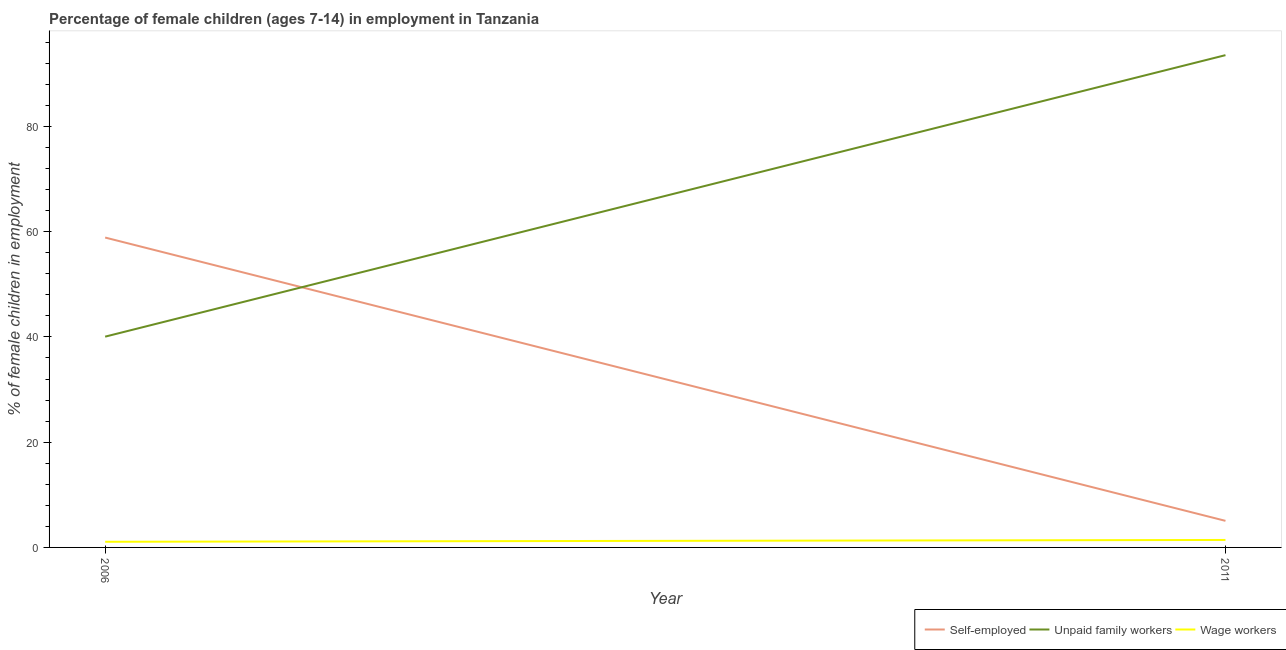How many different coloured lines are there?
Your answer should be compact. 3. Does the line corresponding to percentage of children employed as wage workers intersect with the line corresponding to percentage of self employed children?
Your response must be concise. No. Is the number of lines equal to the number of legend labels?
Provide a short and direct response. Yes. What is the percentage of self employed children in 2011?
Make the answer very short. 5.05. Across all years, what is the maximum percentage of children employed as wage workers?
Offer a terse response. 1.42. Across all years, what is the minimum percentage of children employed as wage workers?
Provide a succinct answer. 1.07. In which year was the percentage of children employed as unpaid family workers maximum?
Your answer should be compact. 2011. In which year was the percentage of self employed children minimum?
Offer a terse response. 2011. What is the total percentage of children employed as wage workers in the graph?
Provide a short and direct response. 2.49. What is the difference between the percentage of children employed as unpaid family workers in 2006 and that in 2011?
Provide a succinct answer. -53.49. What is the difference between the percentage of children employed as wage workers in 2011 and the percentage of self employed children in 2006?
Offer a terse response. -57.46. What is the average percentage of children employed as unpaid family workers per year?
Offer a very short reply. 66.8. In the year 2011, what is the difference between the percentage of self employed children and percentage of children employed as unpaid family workers?
Your response must be concise. -88.49. What is the ratio of the percentage of self employed children in 2006 to that in 2011?
Your response must be concise. 11.66. In how many years, is the percentage of self employed children greater than the average percentage of self employed children taken over all years?
Your answer should be compact. 1. Is it the case that in every year, the sum of the percentage of self employed children and percentage of children employed as unpaid family workers is greater than the percentage of children employed as wage workers?
Ensure brevity in your answer.  Yes. Does the percentage of self employed children monotonically increase over the years?
Make the answer very short. No. Is the percentage of children employed as unpaid family workers strictly greater than the percentage of self employed children over the years?
Give a very brief answer. No. How many years are there in the graph?
Your answer should be compact. 2. Are the values on the major ticks of Y-axis written in scientific E-notation?
Provide a succinct answer. No. Does the graph contain grids?
Offer a terse response. No. How many legend labels are there?
Your answer should be very brief. 3. How are the legend labels stacked?
Make the answer very short. Horizontal. What is the title of the graph?
Your response must be concise. Percentage of female children (ages 7-14) in employment in Tanzania. What is the label or title of the Y-axis?
Make the answer very short. % of female children in employment. What is the % of female children in employment of Self-employed in 2006?
Your response must be concise. 58.88. What is the % of female children in employment in Unpaid family workers in 2006?
Give a very brief answer. 40.05. What is the % of female children in employment of Wage workers in 2006?
Keep it short and to the point. 1.07. What is the % of female children in employment in Self-employed in 2011?
Offer a very short reply. 5.05. What is the % of female children in employment of Unpaid family workers in 2011?
Keep it short and to the point. 93.54. What is the % of female children in employment in Wage workers in 2011?
Make the answer very short. 1.42. Across all years, what is the maximum % of female children in employment in Self-employed?
Your answer should be compact. 58.88. Across all years, what is the maximum % of female children in employment in Unpaid family workers?
Offer a very short reply. 93.54. Across all years, what is the maximum % of female children in employment in Wage workers?
Your response must be concise. 1.42. Across all years, what is the minimum % of female children in employment of Self-employed?
Your answer should be very brief. 5.05. Across all years, what is the minimum % of female children in employment of Unpaid family workers?
Provide a short and direct response. 40.05. Across all years, what is the minimum % of female children in employment in Wage workers?
Make the answer very short. 1.07. What is the total % of female children in employment in Self-employed in the graph?
Keep it short and to the point. 63.93. What is the total % of female children in employment of Unpaid family workers in the graph?
Offer a very short reply. 133.59. What is the total % of female children in employment of Wage workers in the graph?
Provide a succinct answer. 2.49. What is the difference between the % of female children in employment of Self-employed in 2006 and that in 2011?
Offer a very short reply. 53.83. What is the difference between the % of female children in employment in Unpaid family workers in 2006 and that in 2011?
Your answer should be compact. -53.49. What is the difference between the % of female children in employment of Wage workers in 2006 and that in 2011?
Provide a short and direct response. -0.35. What is the difference between the % of female children in employment in Self-employed in 2006 and the % of female children in employment in Unpaid family workers in 2011?
Ensure brevity in your answer.  -34.66. What is the difference between the % of female children in employment of Self-employed in 2006 and the % of female children in employment of Wage workers in 2011?
Give a very brief answer. 57.46. What is the difference between the % of female children in employment in Unpaid family workers in 2006 and the % of female children in employment in Wage workers in 2011?
Make the answer very short. 38.63. What is the average % of female children in employment in Self-employed per year?
Provide a succinct answer. 31.96. What is the average % of female children in employment of Unpaid family workers per year?
Ensure brevity in your answer.  66.8. What is the average % of female children in employment in Wage workers per year?
Your response must be concise. 1.25. In the year 2006, what is the difference between the % of female children in employment in Self-employed and % of female children in employment in Unpaid family workers?
Offer a very short reply. 18.83. In the year 2006, what is the difference between the % of female children in employment in Self-employed and % of female children in employment in Wage workers?
Ensure brevity in your answer.  57.81. In the year 2006, what is the difference between the % of female children in employment in Unpaid family workers and % of female children in employment in Wage workers?
Give a very brief answer. 38.98. In the year 2011, what is the difference between the % of female children in employment of Self-employed and % of female children in employment of Unpaid family workers?
Your answer should be compact. -88.49. In the year 2011, what is the difference between the % of female children in employment in Self-employed and % of female children in employment in Wage workers?
Give a very brief answer. 3.63. In the year 2011, what is the difference between the % of female children in employment in Unpaid family workers and % of female children in employment in Wage workers?
Ensure brevity in your answer.  92.12. What is the ratio of the % of female children in employment in Self-employed in 2006 to that in 2011?
Your response must be concise. 11.66. What is the ratio of the % of female children in employment in Unpaid family workers in 2006 to that in 2011?
Your answer should be compact. 0.43. What is the ratio of the % of female children in employment in Wage workers in 2006 to that in 2011?
Keep it short and to the point. 0.75. What is the difference between the highest and the second highest % of female children in employment in Self-employed?
Your response must be concise. 53.83. What is the difference between the highest and the second highest % of female children in employment of Unpaid family workers?
Keep it short and to the point. 53.49. What is the difference between the highest and the lowest % of female children in employment in Self-employed?
Ensure brevity in your answer.  53.83. What is the difference between the highest and the lowest % of female children in employment of Unpaid family workers?
Make the answer very short. 53.49. 